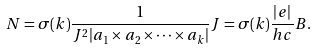<formula> <loc_0><loc_0><loc_500><loc_500>N = \sigma ( k ) \frac { 1 } { J ^ { 2 } | { a } _ { 1 } \times { a } _ { 2 } \times \cdots \times { a } _ { k } | } J = \sigma ( k ) \frac { | e | } { h c } B .</formula> 